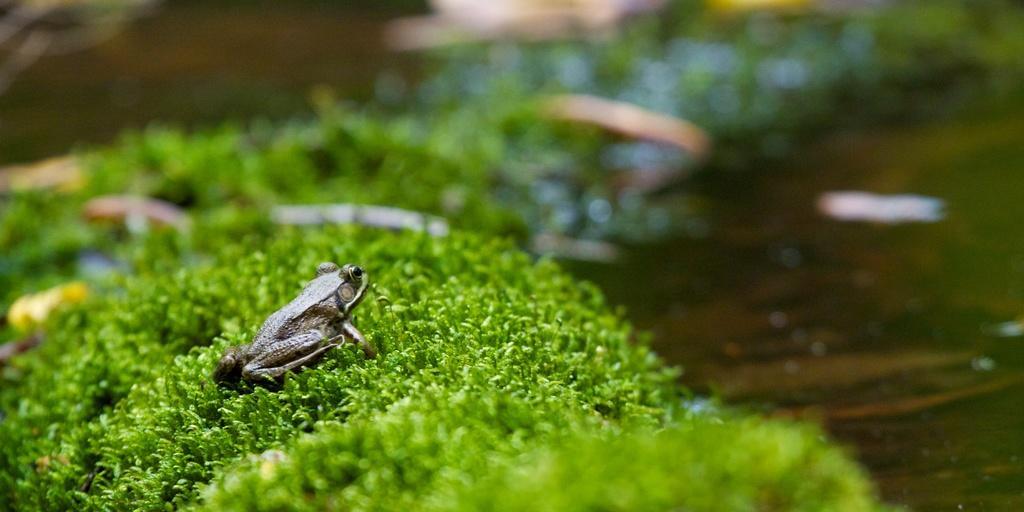Describe this image in one or two sentences. In this picture we can see frog on the green grass. In the background of the image it is blurry. 